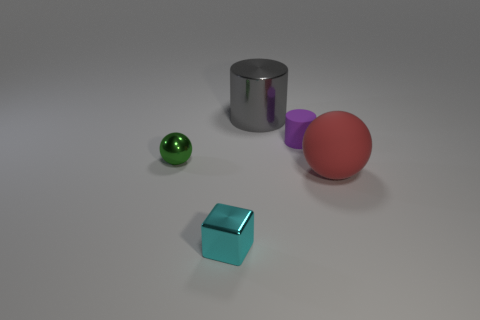Are there any small green spheres left of the green thing?
Ensure brevity in your answer.  No. Are there more gray shiny things in front of the tiny shiny sphere than green metal things behind the big shiny thing?
Provide a short and direct response. No. What is the size of the gray metal object that is the same shape as the purple matte thing?
Offer a terse response. Large. What number of cylinders are tiny cyan metallic objects or green things?
Ensure brevity in your answer.  0. Are there fewer tiny purple matte objects on the right side of the small purple matte thing than small cylinders that are in front of the large metallic object?
Offer a very short reply. Yes. What number of objects are small things that are behind the small ball or tiny metallic balls?
Provide a succinct answer. 2. What is the shape of the small object that is on the right side of the shiny thing that is in front of the red rubber sphere?
Provide a succinct answer. Cylinder. Are there any gray metal objects that have the same size as the red thing?
Offer a very short reply. Yes. Are there more small cyan blocks than cyan shiny cylinders?
Ensure brevity in your answer.  Yes. There is a sphere that is in front of the metal sphere; is it the same size as the metal thing that is left of the tiny cyan thing?
Your answer should be very brief. No. 